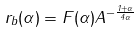Convert formula to latex. <formula><loc_0><loc_0><loc_500><loc_500>r _ { b } ( \alpha ) = F ( \alpha ) A ^ { - \frac { 1 + \alpha } { 4 \alpha } }</formula> 